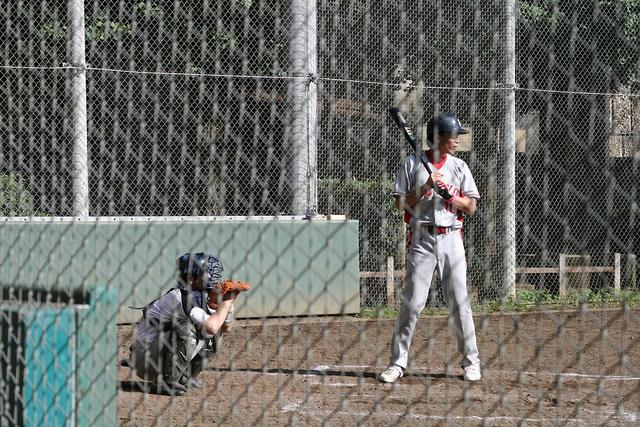Is this a professional team?
Answer briefly. No. What color is the shirt of the team not batting?
Be succinct. White. How many people are standing?
Answer briefly. 1. What base is the batter standing on?
Answer briefly. Home plate. 